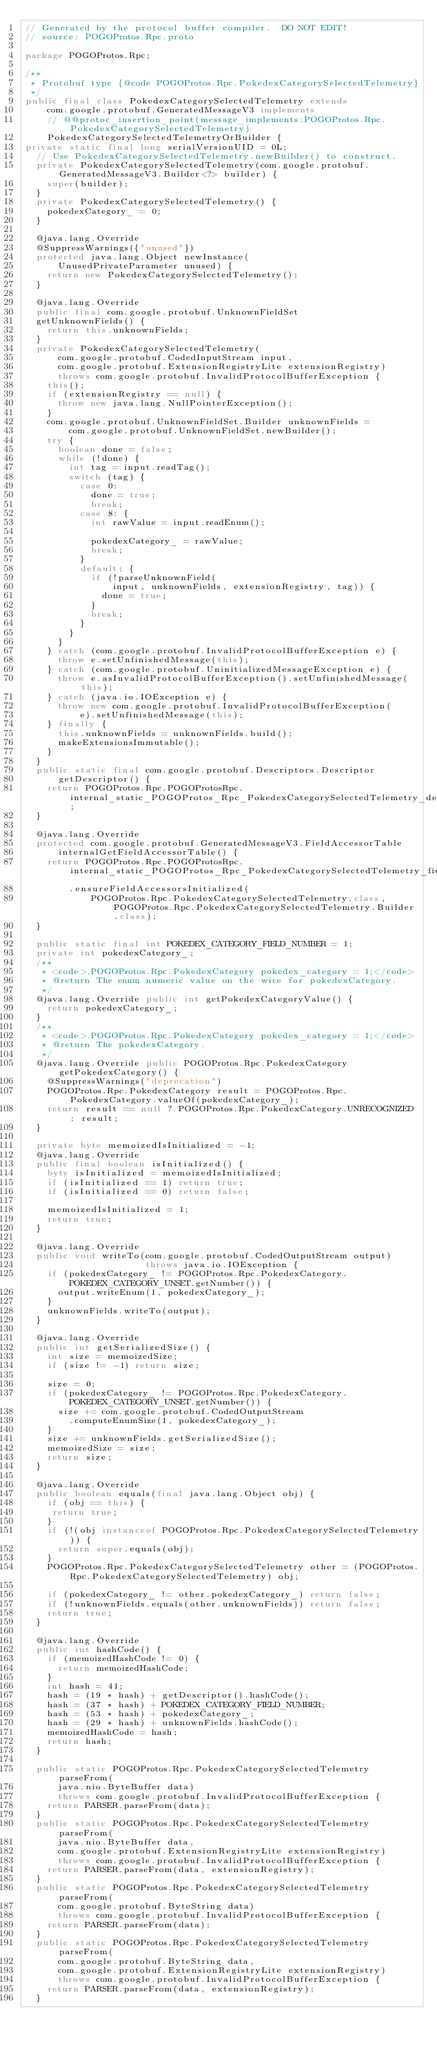<code> <loc_0><loc_0><loc_500><loc_500><_Java_>// Generated by the protocol buffer compiler.  DO NOT EDIT!
// source: POGOProtos.Rpc.proto

package POGOProtos.Rpc;

/**
 * Protobuf type {@code POGOProtos.Rpc.PokedexCategorySelectedTelemetry}
 */
public final class PokedexCategorySelectedTelemetry extends
    com.google.protobuf.GeneratedMessageV3 implements
    // @@protoc_insertion_point(message_implements:POGOProtos.Rpc.PokedexCategorySelectedTelemetry)
    PokedexCategorySelectedTelemetryOrBuilder {
private static final long serialVersionUID = 0L;
  // Use PokedexCategorySelectedTelemetry.newBuilder() to construct.
  private PokedexCategorySelectedTelemetry(com.google.protobuf.GeneratedMessageV3.Builder<?> builder) {
    super(builder);
  }
  private PokedexCategorySelectedTelemetry() {
    pokedexCategory_ = 0;
  }

  @java.lang.Override
  @SuppressWarnings({"unused"})
  protected java.lang.Object newInstance(
      UnusedPrivateParameter unused) {
    return new PokedexCategorySelectedTelemetry();
  }

  @java.lang.Override
  public final com.google.protobuf.UnknownFieldSet
  getUnknownFields() {
    return this.unknownFields;
  }
  private PokedexCategorySelectedTelemetry(
      com.google.protobuf.CodedInputStream input,
      com.google.protobuf.ExtensionRegistryLite extensionRegistry)
      throws com.google.protobuf.InvalidProtocolBufferException {
    this();
    if (extensionRegistry == null) {
      throw new java.lang.NullPointerException();
    }
    com.google.protobuf.UnknownFieldSet.Builder unknownFields =
        com.google.protobuf.UnknownFieldSet.newBuilder();
    try {
      boolean done = false;
      while (!done) {
        int tag = input.readTag();
        switch (tag) {
          case 0:
            done = true;
            break;
          case 8: {
            int rawValue = input.readEnum();

            pokedexCategory_ = rawValue;
            break;
          }
          default: {
            if (!parseUnknownField(
                input, unknownFields, extensionRegistry, tag)) {
              done = true;
            }
            break;
          }
        }
      }
    } catch (com.google.protobuf.InvalidProtocolBufferException e) {
      throw e.setUnfinishedMessage(this);
    } catch (com.google.protobuf.UninitializedMessageException e) {
      throw e.asInvalidProtocolBufferException().setUnfinishedMessage(this);
    } catch (java.io.IOException e) {
      throw new com.google.protobuf.InvalidProtocolBufferException(
          e).setUnfinishedMessage(this);
    } finally {
      this.unknownFields = unknownFields.build();
      makeExtensionsImmutable();
    }
  }
  public static final com.google.protobuf.Descriptors.Descriptor
      getDescriptor() {
    return POGOProtos.Rpc.POGOProtosRpc.internal_static_POGOProtos_Rpc_PokedexCategorySelectedTelemetry_descriptor;
  }

  @java.lang.Override
  protected com.google.protobuf.GeneratedMessageV3.FieldAccessorTable
      internalGetFieldAccessorTable() {
    return POGOProtos.Rpc.POGOProtosRpc.internal_static_POGOProtos_Rpc_PokedexCategorySelectedTelemetry_fieldAccessorTable
        .ensureFieldAccessorsInitialized(
            POGOProtos.Rpc.PokedexCategorySelectedTelemetry.class, POGOProtos.Rpc.PokedexCategorySelectedTelemetry.Builder.class);
  }

  public static final int POKEDEX_CATEGORY_FIELD_NUMBER = 1;
  private int pokedexCategory_;
  /**
   * <code>.POGOProtos.Rpc.PokedexCategory pokedex_category = 1;</code>
   * @return The enum numeric value on the wire for pokedexCategory.
   */
  @java.lang.Override public int getPokedexCategoryValue() {
    return pokedexCategory_;
  }
  /**
   * <code>.POGOProtos.Rpc.PokedexCategory pokedex_category = 1;</code>
   * @return The pokedexCategory.
   */
  @java.lang.Override public POGOProtos.Rpc.PokedexCategory getPokedexCategory() {
    @SuppressWarnings("deprecation")
    POGOProtos.Rpc.PokedexCategory result = POGOProtos.Rpc.PokedexCategory.valueOf(pokedexCategory_);
    return result == null ? POGOProtos.Rpc.PokedexCategory.UNRECOGNIZED : result;
  }

  private byte memoizedIsInitialized = -1;
  @java.lang.Override
  public final boolean isInitialized() {
    byte isInitialized = memoizedIsInitialized;
    if (isInitialized == 1) return true;
    if (isInitialized == 0) return false;

    memoizedIsInitialized = 1;
    return true;
  }

  @java.lang.Override
  public void writeTo(com.google.protobuf.CodedOutputStream output)
                      throws java.io.IOException {
    if (pokedexCategory_ != POGOProtos.Rpc.PokedexCategory.POKEDEX_CATEGORY_UNSET.getNumber()) {
      output.writeEnum(1, pokedexCategory_);
    }
    unknownFields.writeTo(output);
  }

  @java.lang.Override
  public int getSerializedSize() {
    int size = memoizedSize;
    if (size != -1) return size;

    size = 0;
    if (pokedexCategory_ != POGOProtos.Rpc.PokedexCategory.POKEDEX_CATEGORY_UNSET.getNumber()) {
      size += com.google.protobuf.CodedOutputStream
        .computeEnumSize(1, pokedexCategory_);
    }
    size += unknownFields.getSerializedSize();
    memoizedSize = size;
    return size;
  }

  @java.lang.Override
  public boolean equals(final java.lang.Object obj) {
    if (obj == this) {
     return true;
    }
    if (!(obj instanceof POGOProtos.Rpc.PokedexCategorySelectedTelemetry)) {
      return super.equals(obj);
    }
    POGOProtos.Rpc.PokedexCategorySelectedTelemetry other = (POGOProtos.Rpc.PokedexCategorySelectedTelemetry) obj;

    if (pokedexCategory_ != other.pokedexCategory_) return false;
    if (!unknownFields.equals(other.unknownFields)) return false;
    return true;
  }

  @java.lang.Override
  public int hashCode() {
    if (memoizedHashCode != 0) {
      return memoizedHashCode;
    }
    int hash = 41;
    hash = (19 * hash) + getDescriptor().hashCode();
    hash = (37 * hash) + POKEDEX_CATEGORY_FIELD_NUMBER;
    hash = (53 * hash) + pokedexCategory_;
    hash = (29 * hash) + unknownFields.hashCode();
    memoizedHashCode = hash;
    return hash;
  }

  public static POGOProtos.Rpc.PokedexCategorySelectedTelemetry parseFrom(
      java.nio.ByteBuffer data)
      throws com.google.protobuf.InvalidProtocolBufferException {
    return PARSER.parseFrom(data);
  }
  public static POGOProtos.Rpc.PokedexCategorySelectedTelemetry parseFrom(
      java.nio.ByteBuffer data,
      com.google.protobuf.ExtensionRegistryLite extensionRegistry)
      throws com.google.protobuf.InvalidProtocolBufferException {
    return PARSER.parseFrom(data, extensionRegistry);
  }
  public static POGOProtos.Rpc.PokedexCategorySelectedTelemetry parseFrom(
      com.google.protobuf.ByteString data)
      throws com.google.protobuf.InvalidProtocolBufferException {
    return PARSER.parseFrom(data);
  }
  public static POGOProtos.Rpc.PokedexCategorySelectedTelemetry parseFrom(
      com.google.protobuf.ByteString data,
      com.google.protobuf.ExtensionRegistryLite extensionRegistry)
      throws com.google.protobuf.InvalidProtocolBufferException {
    return PARSER.parseFrom(data, extensionRegistry);
  }</code> 